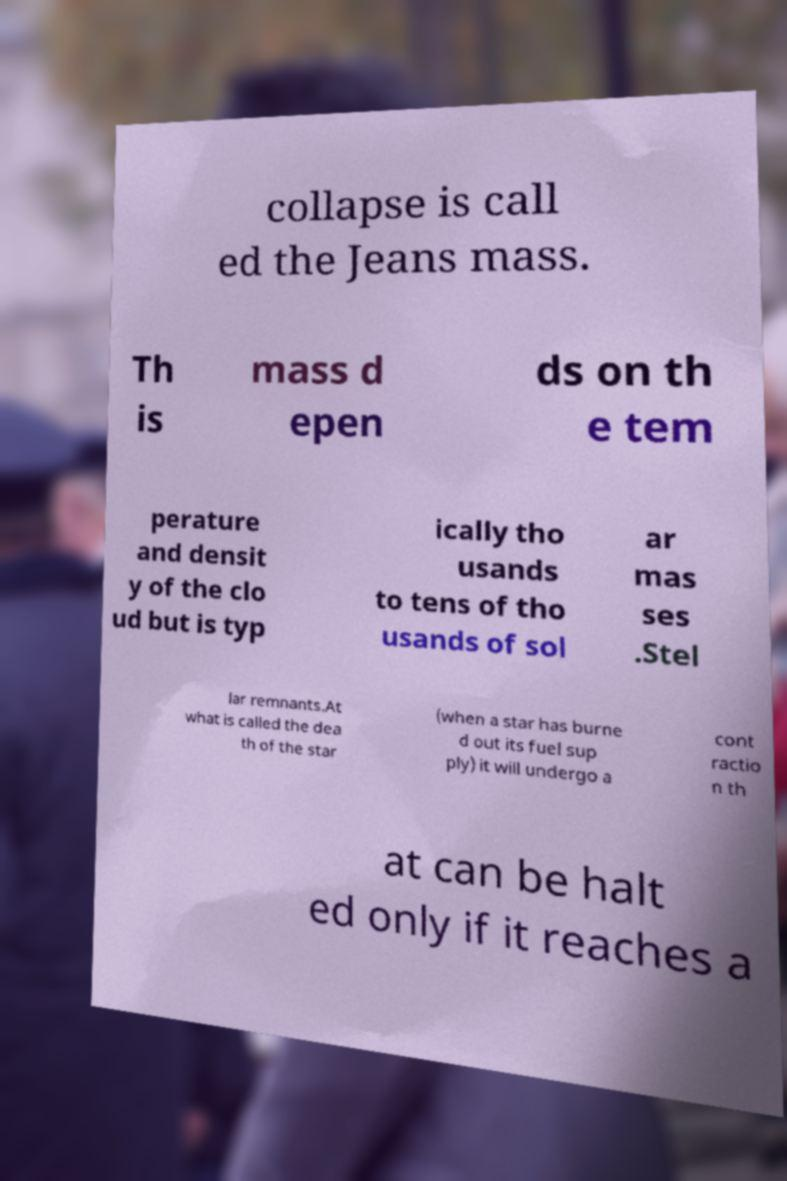I need the written content from this picture converted into text. Can you do that? collapse is call ed the Jeans mass. Th is mass d epen ds on th e tem perature and densit y of the clo ud but is typ ically tho usands to tens of tho usands of sol ar mas ses .Stel lar remnants.At what is called the dea th of the star (when a star has burne d out its fuel sup ply) it will undergo a cont ractio n th at can be halt ed only if it reaches a 